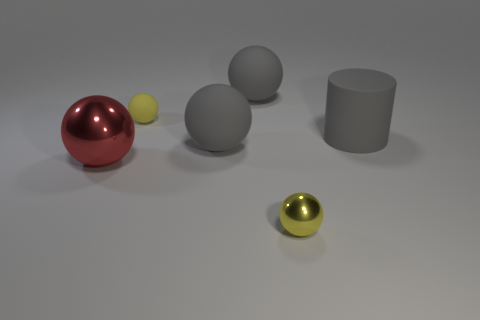What number of tiny objects are either gray spheres or brown rubber spheres?
Offer a terse response. 0. What is the size of the red thing?
Make the answer very short. Large. Is there any other thing that has the same material as the cylinder?
Keep it short and to the point. Yes. There is a gray cylinder; what number of small yellow metal balls are on the left side of it?
Provide a short and direct response. 1. The red shiny thing that is the same shape as the yellow metallic thing is what size?
Make the answer very short. Large. There is a tiny rubber sphere; is it the same color as the tiny object to the right of the tiny rubber ball?
Your response must be concise. Yes. What number of brown things are either large rubber things or large cylinders?
Your answer should be very brief. 0. How many other things are there of the same shape as the tiny metallic thing?
Offer a terse response. 4. There is a large rubber sphere behind the big matte cylinder; what color is it?
Ensure brevity in your answer.  Gray. What number of objects are yellow metal balls or gray objects to the right of the red metal sphere?
Provide a short and direct response. 4. 